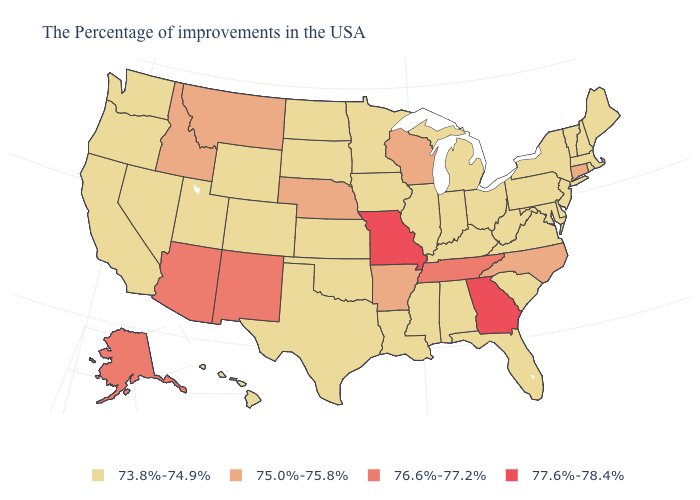What is the value of New York?
Give a very brief answer. 73.8%-74.9%. What is the value of Minnesota?
Short answer required. 73.8%-74.9%. What is the lowest value in the West?
Keep it brief. 73.8%-74.9%. Name the states that have a value in the range 75.0%-75.8%?
Short answer required. Connecticut, North Carolina, Wisconsin, Arkansas, Nebraska, Montana, Idaho. What is the lowest value in the West?
Give a very brief answer. 73.8%-74.9%. What is the value of Ohio?
Keep it brief. 73.8%-74.9%. What is the highest value in the USA?
Write a very short answer. 77.6%-78.4%. Does Kentucky have the lowest value in the South?
Be succinct. Yes. Does Colorado have the lowest value in the West?
Be succinct. Yes. Does North Carolina have the lowest value in the South?
Keep it brief. No. What is the highest value in the South ?
Keep it brief. 77.6%-78.4%. Name the states that have a value in the range 73.8%-74.9%?
Give a very brief answer. Maine, Massachusetts, Rhode Island, New Hampshire, Vermont, New York, New Jersey, Delaware, Maryland, Pennsylvania, Virginia, South Carolina, West Virginia, Ohio, Florida, Michigan, Kentucky, Indiana, Alabama, Illinois, Mississippi, Louisiana, Minnesota, Iowa, Kansas, Oklahoma, Texas, South Dakota, North Dakota, Wyoming, Colorado, Utah, Nevada, California, Washington, Oregon, Hawaii. Among the states that border Louisiana , which have the highest value?
Write a very short answer. Arkansas. How many symbols are there in the legend?
Answer briefly. 4. 